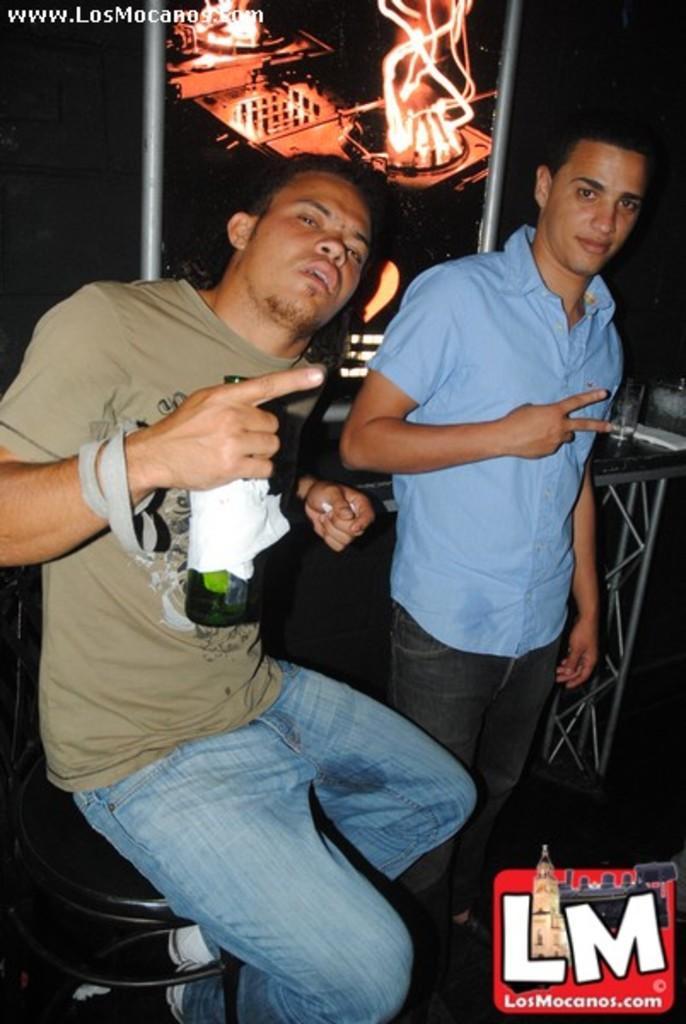Describe this image in one or two sentences. In this image, we can see people and one of them is sitting on the chair and holding a bottle. In the background, there is some text and we can see a table and a glass and there is fire. At the bottom, there is a logo. 